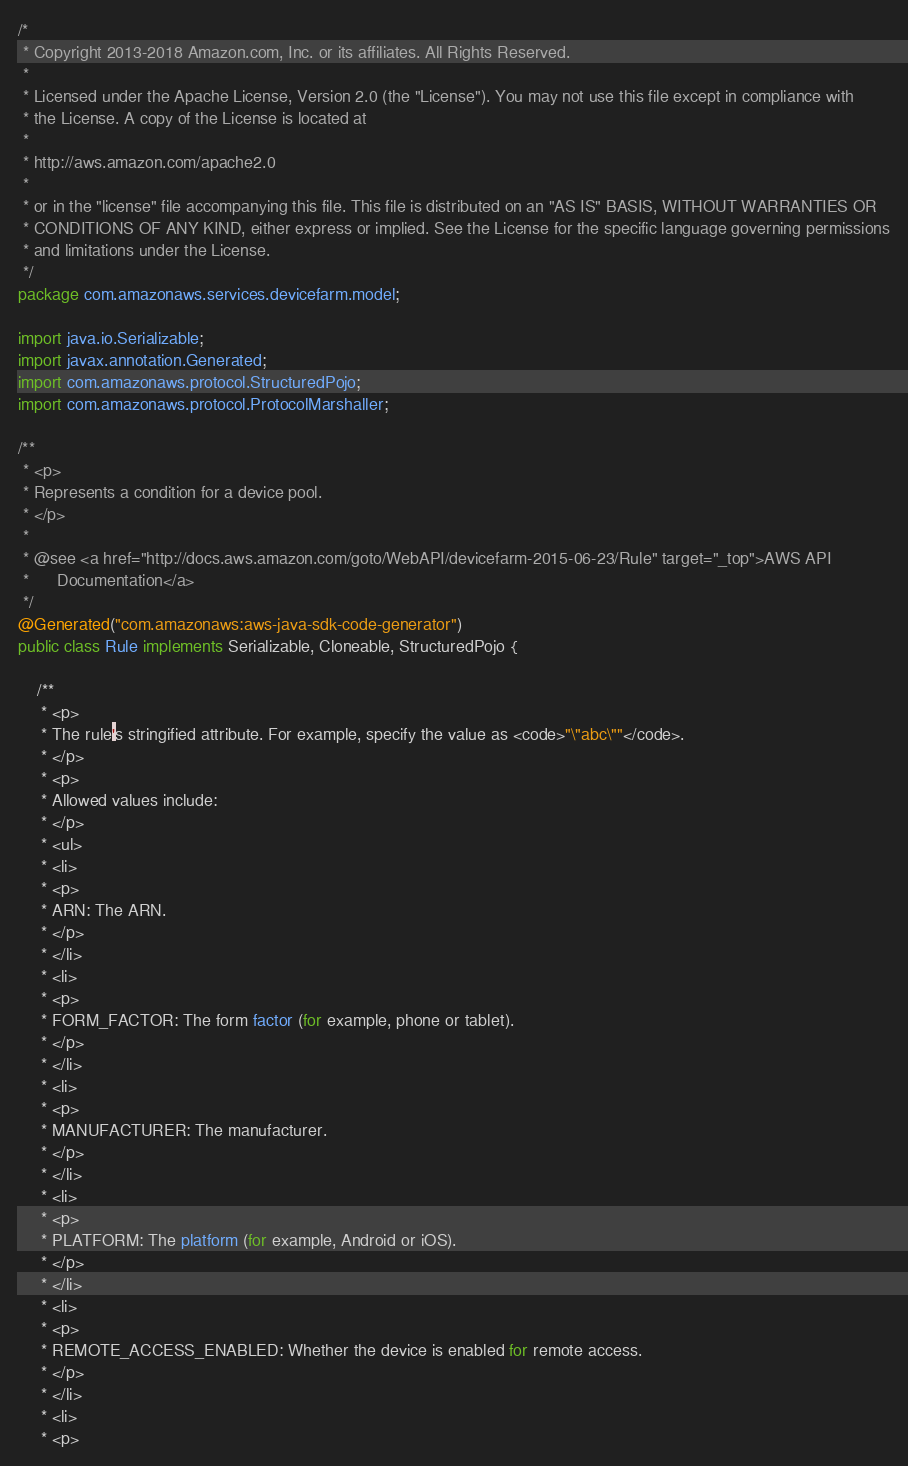Convert code to text. <code><loc_0><loc_0><loc_500><loc_500><_Java_>/*
 * Copyright 2013-2018 Amazon.com, Inc. or its affiliates. All Rights Reserved.
 * 
 * Licensed under the Apache License, Version 2.0 (the "License"). You may not use this file except in compliance with
 * the License. A copy of the License is located at
 * 
 * http://aws.amazon.com/apache2.0
 * 
 * or in the "license" file accompanying this file. This file is distributed on an "AS IS" BASIS, WITHOUT WARRANTIES OR
 * CONDITIONS OF ANY KIND, either express or implied. See the License for the specific language governing permissions
 * and limitations under the License.
 */
package com.amazonaws.services.devicefarm.model;

import java.io.Serializable;
import javax.annotation.Generated;
import com.amazonaws.protocol.StructuredPojo;
import com.amazonaws.protocol.ProtocolMarshaller;

/**
 * <p>
 * Represents a condition for a device pool.
 * </p>
 * 
 * @see <a href="http://docs.aws.amazon.com/goto/WebAPI/devicefarm-2015-06-23/Rule" target="_top">AWS API
 *      Documentation</a>
 */
@Generated("com.amazonaws:aws-java-sdk-code-generator")
public class Rule implements Serializable, Cloneable, StructuredPojo {

    /**
     * <p>
     * The rule's stringified attribute. For example, specify the value as <code>"\"abc\""</code>.
     * </p>
     * <p>
     * Allowed values include:
     * </p>
     * <ul>
     * <li>
     * <p>
     * ARN: The ARN.
     * </p>
     * </li>
     * <li>
     * <p>
     * FORM_FACTOR: The form factor (for example, phone or tablet).
     * </p>
     * </li>
     * <li>
     * <p>
     * MANUFACTURER: The manufacturer.
     * </p>
     * </li>
     * <li>
     * <p>
     * PLATFORM: The platform (for example, Android or iOS).
     * </p>
     * </li>
     * <li>
     * <p>
     * REMOTE_ACCESS_ENABLED: Whether the device is enabled for remote access.
     * </p>
     * </li>
     * <li>
     * <p></code> 